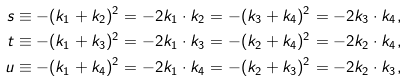Convert formula to latex. <formula><loc_0><loc_0><loc_500><loc_500>s & \equiv - ( k _ { 1 } + k _ { 2 } ) ^ { 2 } = - 2 k _ { 1 } \cdot k _ { 2 } = - ( k _ { 3 } + k _ { 4 } ) ^ { 2 } = - 2 k _ { 3 } \cdot k _ { 4 } , \\ t & \equiv - ( k _ { 1 } + k _ { 3 } ) ^ { 2 } = - 2 k _ { 1 } \cdot k _ { 3 } = - ( k _ { 2 } + k _ { 4 } ) ^ { 2 } = - 2 k _ { 2 } \cdot k _ { 4 } , \\ u & \equiv - ( k _ { 1 } + k _ { 4 } ) ^ { 2 } = - 2 k _ { 1 } \cdot k _ { 4 } = - ( k _ { 2 } + k _ { 3 } ) ^ { 2 } = - 2 k _ { 2 } \cdot k _ { 3 } ,</formula> 